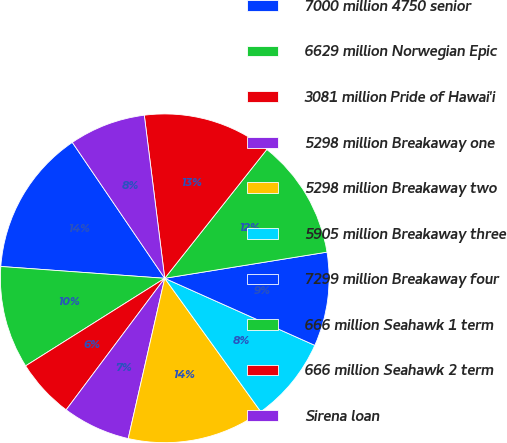Convert chart. <chart><loc_0><loc_0><loc_500><loc_500><pie_chart><fcel>7000 million 4750 senior<fcel>6629 million Norwegian Epic<fcel>3081 million Pride of Hawai'i<fcel>5298 million Breakaway one<fcel>5298 million Breakaway two<fcel>5905 million Breakaway three<fcel>7299 million Breakaway four<fcel>666 million Seahawk 1 term<fcel>666 million Seahawk 2 term<fcel>Sirena loan<nl><fcel>14.35%<fcel>10.09%<fcel>5.82%<fcel>6.67%<fcel>13.5%<fcel>8.38%<fcel>9.23%<fcel>11.79%<fcel>12.65%<fcel>7.52%<nl></chart> 